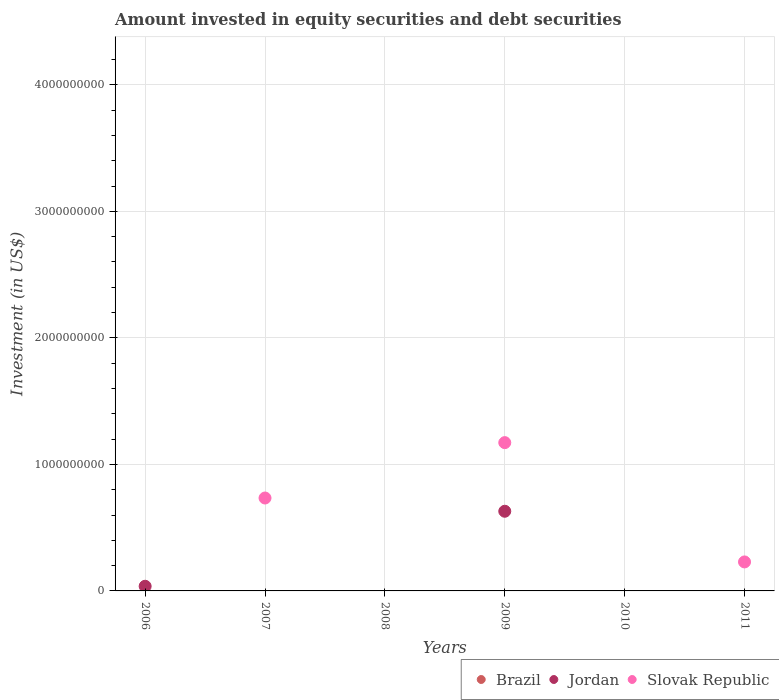Is the number of dotlines equal to the number of legend labels?
Your response must be concise. No. What is the amount invested in equity securities and debt securities in Slovak Republic in 2011?
Your answer should be compact. 2.29e+08. Across all years, what is the maximum amount invested in equity securities and debt securities in Slovak Republic?
Keep it short and to the point. 1.17e+09. Across all years, what is the minimum amount invested in equity securities and debt securities in Slovak Republic?
Ensure brevity in your answer.  0. In which year was the amount invested in equity securities and debt securities in Jordan maximum?
Keep it short and to the point. 2009. What is the total amount invested in equity securities and debt securities in Brazil in the graph?
Your answer should be very brief. 0. What is the difference between the amount invested in equity securities and debt securities in Slovak Republic in 2007 and that in 2011?
Offer a terse response. 5.05e+08. What is the difference between the amount invested in equity securities and debt securities in Jordan in 2006 and the amount invested in equity securities and debt securities in Slovak Republic in 2008?
Offer a terse response. 3.68e+07. What is the average amount invested in equity securities and debt securities in Jordan per year?
Provide a short and direct response. 1.11e+08. In the year 2009, what is the difference between the amount invested in equity securities and debt securities in Slovak Republic and amount invested in equity securities and debt securities in Jordan?
Keep it short and to the point. 5.42e+08. What is the difference between the highest and the second highest amount invested in equity securities and debt securities in Slovak Republic?
Make the answer very short. 4.38e+08. What is the difference between the highest and the lowest amount invested in equity securities and debt securities in Jordan?
Your response must be concise. 6.30e+08. Is the sum of the amount invested in equity securities and debt securities in Slovak Republic in 2007 and 2009 greater than the maximum amount invested in equity securities and debt securities in Brazil across all years?
Give a very brief answer. Yes. Is it the case that in every year, the sum of the amount invested in equity securities and debt securities in Brazil and amount invested in equity securities and debt securities in Jordan  is greater than the amount invested in equity securities and debt securities in Slovak Republic?
Your answer should be compact. No. Does the amount invested in equity securities and debt securities in Jordan monotonically increase over the years?
Your answer should be very brief. No. Is the amount invested in equity securities and debt securities in Jordan strictly greater than the amount invested in equity securities and debt securities in Slovak Republic over the years?
Provide a short and direct response. No. Is the amount invested in equity securities and debt securities in Brazil strictly less than the amount invested in equity securities and debt securities in Slovak Republic over the years?
Ensure brevity in your answer.  No. How many years are there in the graph?
Give a very brief answer. 6. How many legend labels are there?
Ensure brevity in your answer.  3. What is the title of the graph?
Offer a very short reply. Amount invested in equity securities and debt securities. Does "Netherlands" appear as one of the legend labels in the graph?
Your answer should be very brief. No. What is the label or title of the Y-axis?
Ensure brevity in your answer.  Investment (in US$). What is the Investment (in US$) of Brazil in 2006?
Provide a succinct answer. 0. What is the Investment (in US$) in Jordan in 2006?
Give a very brief answer. 3.68e+07. What is the Investment (in US$) in Slovak Republic in 2006?
Ensure brevity in your answer.  0. What is the Investment (in US$) of Brazil in 2007?
Your answer should be very brief. 0. What is the Investment (in US$) of Slovak Republic in 2007?
Offer a terse response. 7.34e+08. What is the Investment (in US$) of Jordan in 2008?
Provide a succinct answer. 0. What is the Investment (in US$) in Slovak Republic in 2008?
Your answer should be compact. 0. What is the Investment (in US$) in Jordan in 2009?
Offer a terse response. 6.30e+08. What is the Investment (in US$) in Slovak Republic in 2009?
Provide a succinct answer. 1.17e+09. What is the Investment (in US$) in Slovak Republic in 2011?
Provide a short and direct response. 2.29e+08. Across all years, what is the maximum Investment (in US$) of Jordan?
Provide a short and direct response. 6.30e+08. Across all years, what is the maximum Investment (in US$) in Slovak Republic?
Ensure brevity in your answer.  1.17e+09. Across all years, what is the minimum Investment (in US$) in Slovak Republic?
Your response must be concise. 0. What is the total Investment (in US$) of Brazil in the graph?
Keep it short and to the point. 0. What is the total Investment (in US$) of Jordan in the graph?
Your answer should be very brief. 6.66e+08. What is the total Investment (in US$) in Slovak Republic in the graph?
Provide a short and direct response. 2.14e+09. What is the difference between the Investment (in US$) of Jordan in 2006 and that in 2009?
Keep it short and to the point. -5.93e+08. What is the difference between the Investment (in US$) of Slovak Republic in 2007 and that in 2009?
Offer a terse response. -4.38e+08. What is the difference between the Investment (in US$) of Slovak Republic in 2007 and that in 2011?
Make the answer very short. 5.05e+08. What is the difference between the Investment (in US$) of Slovak Republic in 2009 and that in 2011?
Ensure brevity in your answer.  9.43e+08. What is the difference between the Investment (in US$) of Jordan in 2006 and the Investment (in US$) of Slovak Republic in 2007?
Your answer should be compact. -6.97e+08. What is the difference between the Investment (in US$) in Jordan in 2006 and the Investment (in US$) in Slovak Republic in 2009?
Your answer should be very brief. -1.14e+09. What is the difference between the Investment (in US$) of Jordan in 2006 and the Investment (in US$) of Slovak Republic in 2011?
Give a very brief answer. -1.92e+08. What is the difference between the Investment (in US$) of Jordan in 2009 and the Investment (in US$) of Slovak Republic in 2011?
Give a very brief answer. 4.00e+08. What is the average Investment (in US$) in Jordan per year?
Make the answer very short. 1.11e+08. What is the average Investment (in US$) of Slovak Republic per year?
Offer a terse response. 3.56e+08. In the year 2009, what is the difference between the Investment (in US$) of Jordan and Investment (in US$) of Slovak Republic?
Your answer should be very brief. -5.42e+08. What is the ratio of the Investment (in US$) of Jordan in 2006 to that in 2009?
Your answer should be very brief. 0.06. What is the ratio of the Investment (in US$) of Slovak Republic in 2007 to that in 2009?
Provide a short and direct response. 0.63. What is the ratio of the Investment (in US$) of Slovak Republic in 2007 to that in 2011?
Give a very brief answer. 3.21. What is the ratio of the Investment (in US$) of Slovak Republic in 2009 to that in 2011?
Offer a terse response. 5.12. What is the difference between the highest and the second highest Investment (in US$) of Slovak Republic?
Ensure brevity in your answer.  4.38e+08. What is the difference between the highest and the lowest Investment (in US$) in Jordan?
Ensure brevity in your answer.  6.30e+08. What is the difference between the highest and the lowest Investment (in US$) of Slovak Republic?
Your response must be concise. 1.17e+09. 